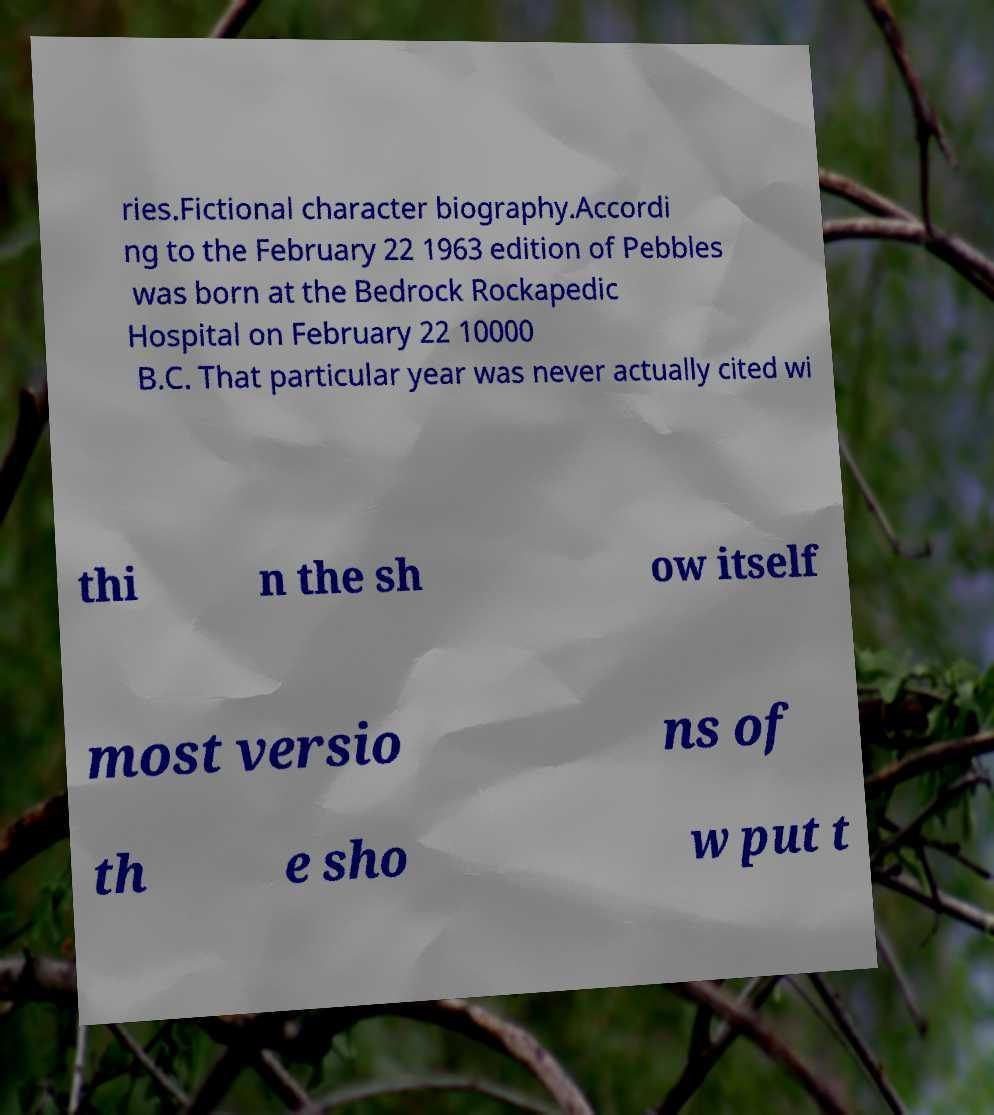For documentation purposes, I need the text within this image transcribed. Could you provide that? ries.Fictional character biography.Accordi ng to the February 22 1963 edition of Pebbles was born at the Bedrock Rockapedic Hospital on February 22 10000 B.C. That particular year was never actually cited wi thi n the sh ow itself most versio ns of th e sho w put t 